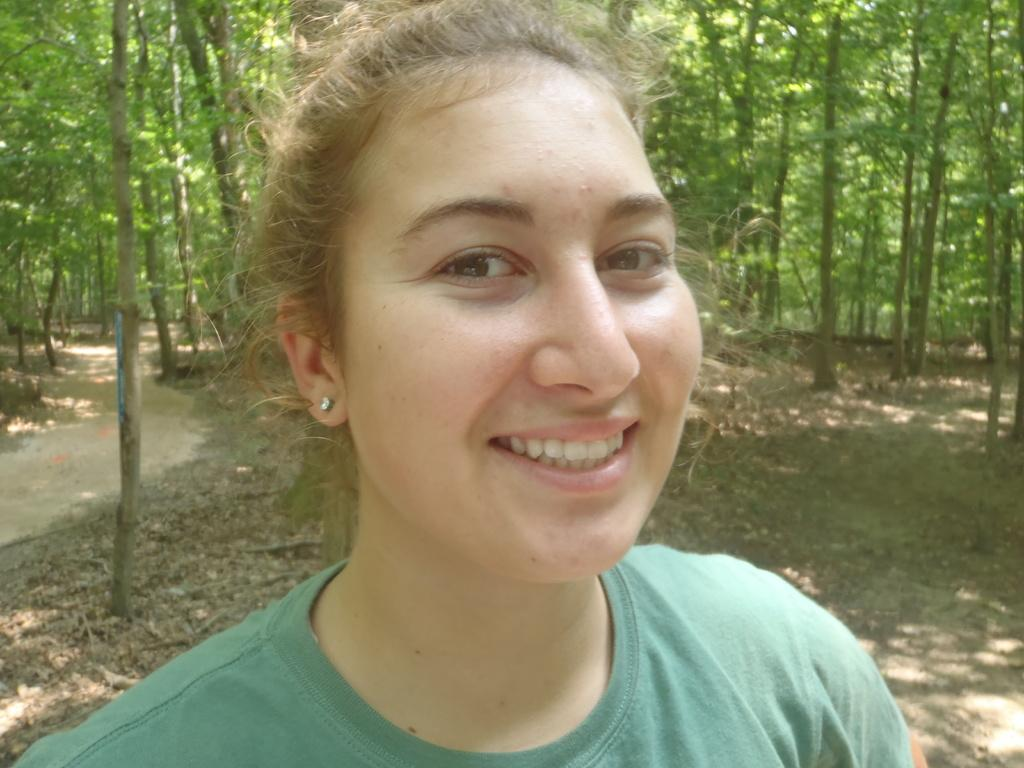Who is the main subject in the image? There is a lady in the center of the image. What can be seen in the background of the image? There are trees in the background of the image. What type of vegetation is present at the bottom of the image? Dry leaves are present at the bottom of the image. How many girls are holding hands with the lady in the image? There are no girls present in the image, only the lady. What type of wristwatch is the lady wearing in the image? There is no wristwatch visible on the lady in the image. 